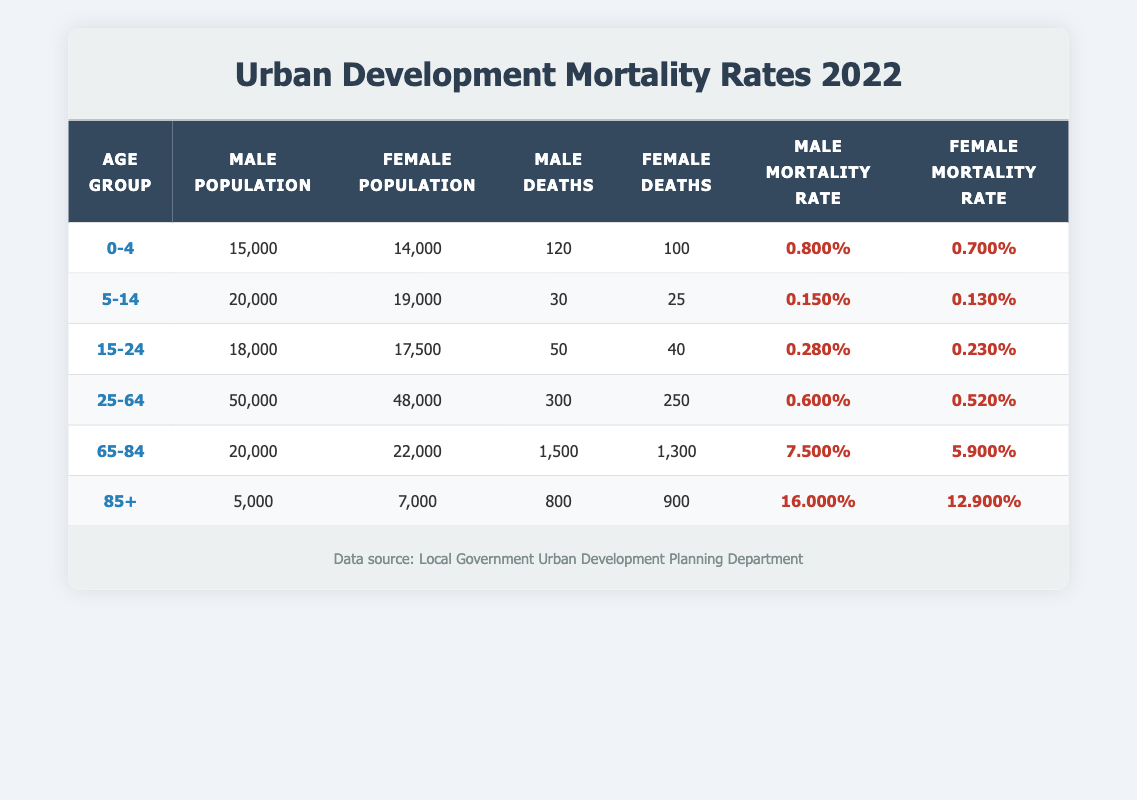What is the male mortality rate for the age group 0-4? The table shows the male mortality rate for the age group 0-4 as 0.800%.
Answer: 0.800% What is the total number of female deaths in the age groups 25-64 and 65-84 combined? From the table, female deaths for age group 25-64 are 250, and for age group 65-84 are 1,300. Adding them gives 250 + 1,300 = 1,550.
Answer: 1,550 Is the female mortality rate higher for the age group 85+ compared to the age group 65-84? The female mortality rate for age group 85+ is 12.900% and for age group 65-84 is 5.900%. Since 12.900% is greater than 5.900%, the statement is true.
Answer: Yes What is the difference in male population between the age groups 5-14 and 0-4? The male population for age group 5-14 is 20,000 and for age group 0-4 is 15,000. The difference is 20,000 - 15,000 = 5,000.
Answer: 5,000 What is the average mortality rate for females across all age groups? To calculate the average, we sum the female mortality rates: 0.007 + 0.0013 + 0.0023 + 0.0052 + 0.059 + 0.129 = 0.2038 and divide by the number of groups (6), yielding 0.2038 / 6 = 0.03397 or approximately 3.4%.
Answer: 3.4% What age group has the highest male mortality rate? Looking at the table, the age group 85+ has the highest male mortality rate at 16.000%.
Answer: 85+ Is the mortality rate for females in the age group 25-64 lower than in the age group 15-24? The female mortality rate for age group 25-64 is 0.520% and for age group 15-24 is 0.230%. Since 0.520% is higher than 0.230%, the statement is false.
Answer: No What is the total male population for the age groups 0-4 and 5-14 combined? From the table, the male population for age group 0-4 is 15,000, and for age group 5-14 is 20,000. Adding these gives 15,000 + 20,000 = 35,000.
Answer: 35,000 Which gender has a higher number of deaths in the age group 65-84? The table shows that in the age group 65-84, there were 1,500 male deaths compared to 1,300 female deaths, indicating that males had a higher number of deaths.
Answer: Male 